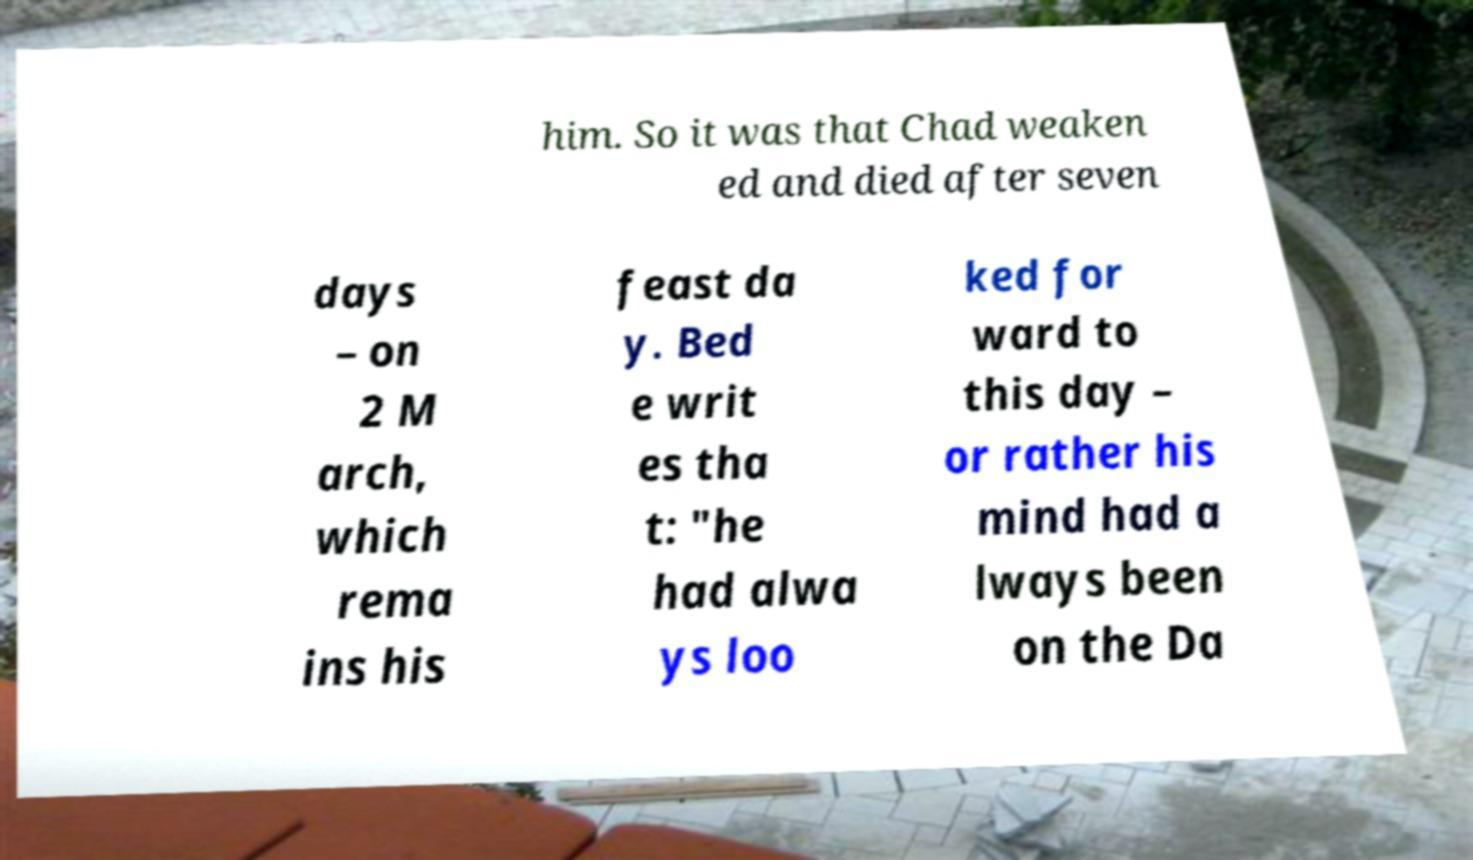Please identify and transcribe the text found in this image. him. So it was that Chad weaken ed and died after seven days – on 2 M arch, which rema ins his feast da y. Bed e writ es tha t: "he had alwa ys loo ked for ward to this day – or rather his mind had a lways been on the Da 